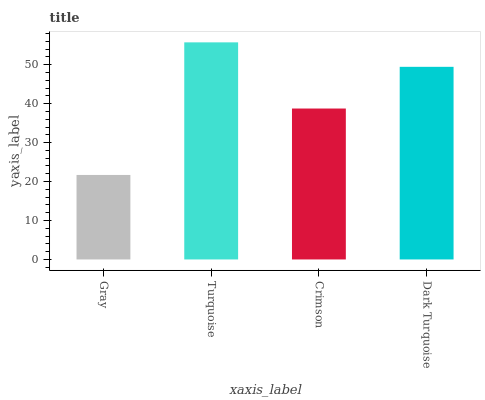Is Gray the minimum?
Answer yes or no. Yes. Is Turquoise the maximum?
Answer yes or no. Yes. Is Crimson the minimum?
Answer yes or no. No. Is Crimson the maximum?
Answer yes or no. No. Is Turquoise greater than Crimson?
Answer yes or no. Yes. Is Crimson less than Turquoise?
Answer yes or no. Yes. Is Crimson greater than Turquoise?
Answer yes or no. No. Is Turquoise less than Crimson?
Answer yes or no. No. Is Dark Turquoise the high median?
Answer yes or no. Yes. Is Crimson the low median?
Answer yes or no. Yes. Is Crimson the high median?
Answer yes or no. No. Is Gray the low median?
Answer yes or no. No. 